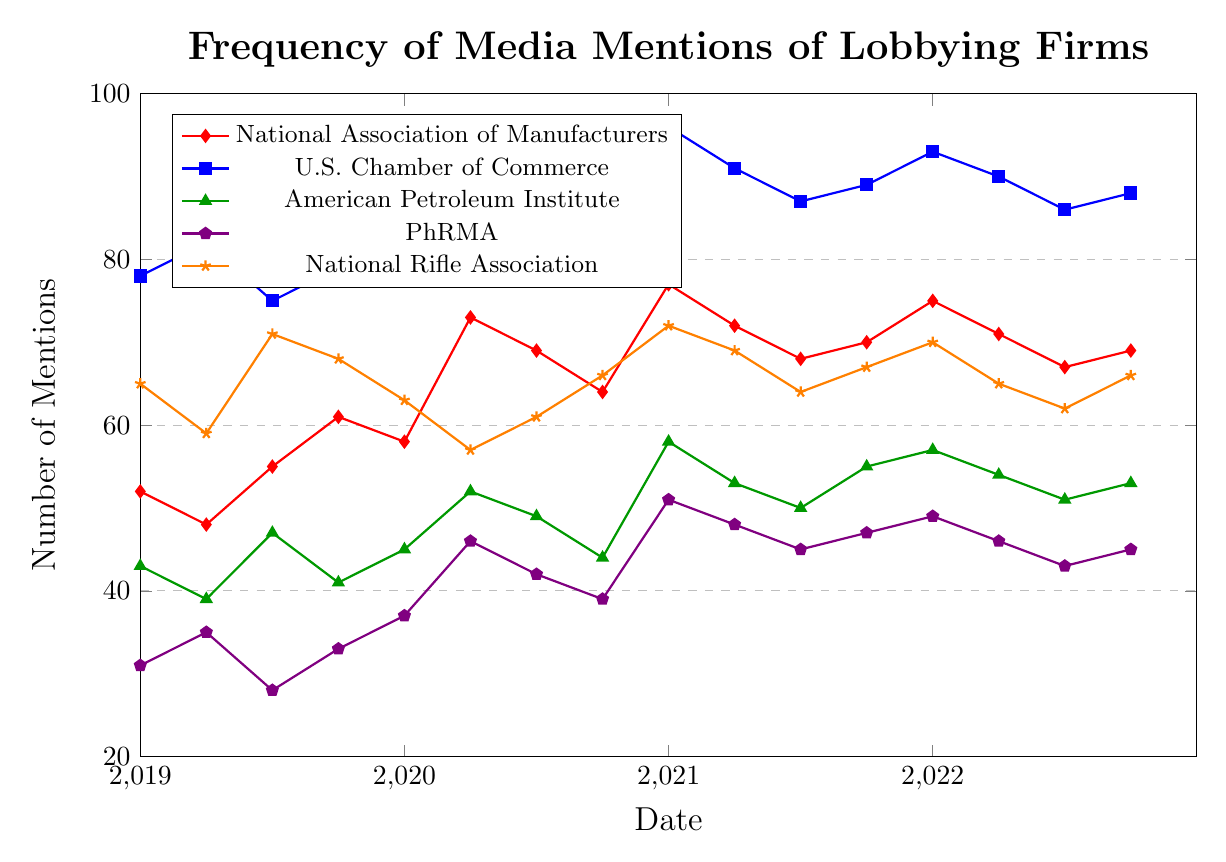What's the overall trend for the National Association of Manufacturers from 2019 to 2022? The mentions for the National Association of Manufacturers generally increase from 52 in 2019-Q1 to a high of 77 in 2021-Q1, and then shows some fluctuations around mid-70s until 2022-Q4.
Answer: Increasing trend with fluctuations Which organization had the highest number of mentions in 2021-Q1? The U.S. Chamber of Commerce had the highest mentions, with the figure reaching 96. Other organizations' mentions were lower.
Answer: U.S. Chamber of Commerce Compare the mentions for the National Rifle Association and PhRMA in 2020-Q4. Which one had more mentions? The mentions in 2020-Q4 for the National Rifle Association are 66, while PhRMA has only 39 mentions.
Answer: National Rifle Association What is the average number of mentions for the American Petroleum Institute across all the quarters? Add up all the mentions for each quarter for the American Petroleum Institute and divide by the number of quarters: (43 + 39 + 47 + 41 + 45 + 52 + 49 + 44 + 58 + 53 + 50 + 55 + 57 + 54 + 51 + 53) / 16 = 750 / 16 = 46.875.
Answer: 46.875 Which organization experienced the largest increase in mentions from 2020-Q1 to 2020-Q2? For the National Association of Manufacturers, the increase is from 58 to 73 (+15). For the U.S. Chamber of Commerce, it's from 85 to 92 (+7). For the American Petroleum Institute, it's from 45 to 52 (+7). For PhRMA, it's from 37 to 46 (+9). For the National Rifle Association, it's from 63 to 57 (-6). The National Association of Manufacturers saw the largest increase.
Answer: National Association of Manufacturers How do the mentions in 2021-Q2 for the National Rifle Association compare to its mentions in 2019-Q2? In 2021-Q2, the National Rifle Association has 69 mentions, while in 2019-Q2, it has 59 mentions. Thus, its mentions increased by 10.
Answer: Increased by 10 In 2022-Q1, rank the organizations from most to least mentions. In 2022-Q1, U.S. Chamber of Commerce has 93, National Association of Manufacturers has 75, American Petroleum Institute has 57, National Rifle Association has 70, and PhRMA has 49 mentions. The ranking from most to least mentions: U.S. Chamber of Commerce > National Rifle Association > National Association of Manufacturers > American Petroleum Institute > PhRMA.
Answer: U.S. Chamber of Commerce, National Rifle Association, National Association of Manufacturers, American Petroleum Institute, PhRMA What is the smallest number of mentions recorded for PhRMA, and during which quarter did it occur? The smallest number of mentions for PhRMA is 28, which occurs in 2019-Q3.
Answer: 28 in 2019-Q3 Did the National Association of Manufacturers ever have more mentions than the U.S. Chamber of Commerce in any quarter? By visually inspecting the plot, we see that the U.S. Chamber of Commerce consistently has higher mentions in every quarter. Therefore, no, the National Association of Manufacturers never surpassed the U.S. Chamber of Commerce.
Answer: No 